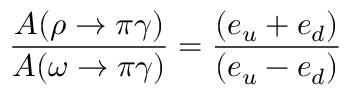Convert formula to latex. <formula><loc_0><loc_0><loc_500><loc_500>\frac { A ( \rho \rightarrow \pi \gamma ) } { A ( \omega \rightarrow \pi \gamma ) } = \frac { ( e _ { u } + e _ { d } ) } { ( e _ { u } - e _ { d } ) }</formula> 